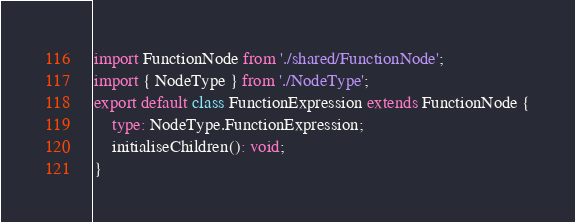Convert code to text. <code><loc_0><loc_0><loc_500><loc_500><_TypeScript_>import FunctionNode from './shared/FunctionNode';
import { NodeType } from './NodeType';
export default class FunctionExpression extends FunctionNode {
    type: NodeType.FunctionExpression;
    initialiseChildren(): void;
}
</code> 